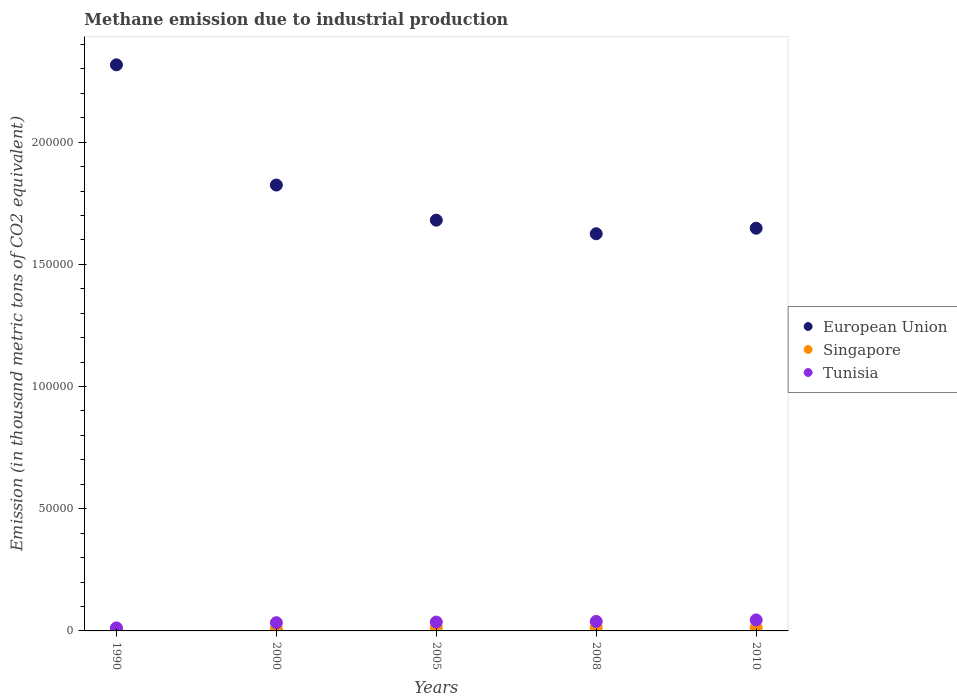How many different coloured dotlines are there?
Your answer should be compact. 3. What is the amount of methane emitted in European Union in 2000?
Offer a terse response. 1.82e+05. Across all years, what is the maximum amount of methane emitted in Tunisia?
Provide a succinct answer. 4497.8. Across all years, what is the minimum amount of methane emitted in Singapore?
Ensure brevity in your answer.  406.8. In which year was the amount of methane emitted in Tunisia maximum?
Your answer should be compact. 2010. In which year was the amount of methane emitted in European Union minimum?
Give a very brief answer. 2008. What is the total amount of methane emitted in Tunisia in the graph?
Offer a terse response. 1.66e+04. What is the difference between the amount of methane emitted in Tunisia in 1990 and that in 2005?
Keep it short and to the point. -2383.1. What is the difference between the amount of methane emitted in Tunisia in 2005 and the amount of methane emitted in Singapore in 2008?
Provide a short and direct response. 2233.4. What is the average amount of methane emitted in Singapore per year?
Offer a terse response. 1082.82. In the year 2005, what is the difference between the amount of methane emitted in Singapore and amount of methane emitted in European Union?
Provide a succinct answer. -1.67e+05. What is the ratio of the amount of methane emitted in Tunisia in 1990 to that in 2005?
Your answer should be very brief. 0.34. Is the amount of methane emitted in Tunisia in 1990 less than that in 2005?
Provide a succinct answer. Yes. What is the difference between the highest and the second highest amount of methane emitted in Tunisia?
Your answer should be compact. 606.2. What is the difference between the highest and the lowest amount of methane emitted in Tunisia?
Make the answer very short. 3260.8. In how many years, is the amount of methane emitted in European Union greater than the average amount of methane emitted in European Union taken over all years?
Offer a very short reply. 2. Is the sum of the amount of methane emitted in Tunisia in 1990 and 2000 greater than the maximum amount of methane emitted in European Union across all years?
Provide a succinct answer. No. How many years are there in the graph?
Your response must be concise. 5. Are the values on the major ticks of Y-axis written in scientific E-notation?
Your answer should be very brief. No. Where does the legend appear in the graph?
Offer a terse response. Center right. What is the title of the graph?
Give a very brief answer. Methane emission due to industrial production. Does "Finland" appear as one of the legend labels in the graph?
Your answer should be very brief. No. What is the label or title of the Y-axis?
Give a very brief answer. Emission (in thousand metric tons of CO2 equivalent). What is the Emission (in thousand metric tons of CO2 equivalent) of European Union in 1990?
Your answer should be compact. 2.32e+05. What is the Emission (in thousand metric tons of CO2 equivalent) in Singapore in 1990?
Keep it short and to the point. 406.8. What is the Emission (in thousand metric tons of CO2 equivalent) in Tunisia in 1990?
Ensure brevity in your answer.  1237. What is the Emission (in thousand metric tons of CO2 equivalent) in European Union in 2000?
Make the answer very short. 1.82e+05. What is the Emission (in thousand metric tons of CO2 equivalent) in Singapore in 2000?
Offer a very short reply. 893.5. What is the Emission (in thousand metric tons of CO2 equivalent) of Tunisia in 2000?
Provide a short and direct response. 3368.9. What is the Emission (in thousand metric tons of CO2 equivalent) of European Union in 2005?
Give a very brief answer. 1.68e+05. What is the Emission (in thousand metric tons of CO2 equivalent) in Singapore in 2005?
Your answer should be very brief. 1383. What is the Emission (in thousand metric tons of CO2 equivalent) of Tunisia in 2005?
Make the answer very short. 3620.1. What is the Emission (in thousand metric tons of CO2 equivalent) in European Union in 2008?
Your answer should be very brief. 1.63e+05. What is the Emission (in thousand metric tons of CO2 equivalent) of Singapore in 2008?
Offer a very short reply. 1386.7. What is the Emission (in thousand metric tons of CO2 equivalent) in Tunisia in 2008?
Offer a terse response. 3891.6. What is the Emission (in thousand metric tons of CO2 equivalent) in European Union in 2010?
Ensure brevity in your answer.  1.65e+05. What is the Emission (in thousand metric tons of CO2 equivalent) of Singapore in 2010?
Provide a succinct answer. 1344.1. What is the Emission (in thousand metric tons of CO2 equivalent) of Tunisia in 2010?
Your answer should be very brief. 4497.8. Across all years, what is the maximum Emission (in thousand metric tons of CO2 equivalent) in European Union?
Offer a terse response. 2.32e+05. Across all years, what is the maximum Emission (in thousand metric tons of CO2 equivalent) of Singapore?
Give a very brief answer. 1386.7. Across all years, what is the maximum Emission (in thousand metric tons of CO2 equivalent) of Tunisia?
Give a very brief answer. 4497.8. Across all years, what is the minimum Emission (in thousand metric tons of CO2 equivalent) of European Union?
Keep it short and to the point. 1.63e+05. Across all years, what is the minimum Emission (in thousand metric tons of CO2 equivalent) of Singapore?
Offer a terse response. 406.8. Across all years, what is the minimum Emission (in thousand metric tons of CO2 equivalent) in Tunisia?
Provide a succinct answer. 1237. What is the total Emission (in thousand metric tons of CO2 equivalent) in European Union in the graph?
Your response must be concise. 9.09e+05. What is the total Emission (in thousand metric tons of CO2 equivalent) in Singapore in the graph?
Keep it short and to the point. 5414.1. What is the total Emission (in thousand metric tons of CO2 equivalent) of Tunisia in the graph?
Your answer should be compact. 1.66e+04. What is the difference between the Emission (in thousand metric tons of CO2 equivalent) in European Union in 1990 and that in 2000?
Provide a short and direct response. 4.92e+04. What is the difference between the Emission (in thousand metric tons of CO2 equivalent) in Singapore in 1990 and that in 2000?
Provide a succinct answer. -486.7. What is the difference between the Emission (in thousand metric tons of CO2 equivalent) in Tunisia in 1990 and that in 2000?
Provide a short and direct response. -2131.9. What is the difference between the Emission (in thousand metric tons of CO2 equivalent) in European Union in 1990 and that in 2005?
Offer a terse response. 6.36e+04. What is the difference between the Emission (in thousand metric tons of CO2 equivalent) of Singapore in 1990 and that in 2005?
Provide a succinct answer. -976.2. What is the difference between the Emission (in thousand metric tons of CO2 equivalent) of Tunisia in 1990 and that in 2005?
Keep it short and to the point. -2383.1. What is the difference between the Emission (in thousand metric tons of CO2 equivalent) in European Union in 1990 and that in 2008?
Ensure brevity in your answer.  6.91e+04. What is the difference between the Emission (in thousand metric tons of CO2 equivalent) in Singapore in 1990 and that in 2008?
Provide a succinct answer. -979.9. What is the difference between the Emission (in thousand metric tons of CO2 equivalent) in Tunisia in 1990 and that in 2008?
Your answer should be very brief. -2654.6. What is the difference between the Emission (in thousand metric tons of CO2 equivalent) in European Union in 1990 and that in 2010?
Offer a very short reply. 6.69e+04. What is the difference between the Emission (in thousand metric tons of CO2 equivalent) in Singapore in 1990 and that in 2010?
Your answer should be compact. -937.3. What is the difference between the Emission (in thousand metric tons of CO2 equivalent) in Tunisia in 1990 and that in 2010?
Offer a terse response. -3260.8. What is the difference between the Emission (in thousand metric tons of CO2 equivalent) in European Union in 2000 and that in 2005?
Ensure brevity in your answer.  1.44e+04. What is the difference between the Emission (in thousand metric tons of CO2 equivalent) of Singapore in 2000 and that in 2005?
Keep it short and to the point. -489.5. What is the difference between the Emission (in thousand metric tons of CO2 equivalent) in Tunisia in 2000 and that in 2005?
Offer a very short reply. -251.2. What is the difference between the Emission (in thousand metric tons of CO2 equivalent) in European Union in 2000 and that in 2008?
Your answer should be compact. 1.99e+04. What is the difference between the Emission (in thousand metric tons of CO2 equivalent) in Singapore in 2000 and that in 2008?
Make the answer very short. -493.2. What is the difference between the Emission (in thousand metric tons of CO2 equivalent) of Tunisia in 2000 and that in 2008?
Give a very brief answer. -522.7. What is the difference between the Emission (in thousand metric tons of CO2 equivalent) of European Union in 2000 and that in 2010?
Offer a very short reply. 1.77e+04. What is the difference between the Emission (in thousand metric tons of CO2 equivalent) of Singapore in 2000 and that in 2010?
Your response must be concise. -450.6. What is the difference between the Emission (in thousand metric tons of CO2 equivalent) in Tunisia in 2000 and that in 2010?
Your answer should be very brief. -1128.9. What is the difference between the Emission (in thousand metric tons of CO2 equivalent) of European Union in 2005 and that in 2008?
Your response must be concise. 5562. What is the difference between the Emission (in thousand metric tons of CO2 equivalent) in Tunisia in 2005 and that in 2008?
Offer a terse response. -271.5. What is the difference between the Emission (in thousand metric tons of CO2 equivalent) in European Union in 2005 and that in 2010?
Offer a terse response. 3298.2. What is the difference between the Emission (in thousand metric tons of CO2 equivalent) of Singapore in 2005 and that in 2010?
Give a very brief answer. 38.9. What is the difference between the Emission (in thousand metric tons of CO2 equivalent) of Tunisia in 2005 and that in 2010?
Give a very brief answer. -877.7. What is the difference between the Emission (in thousand metric tons of CO2 equivalent) of European Union in 2008 and that in 2010?
Offer a terse response. -2263.8. What is the difference between the Emission (in thousand metric tons of CO2 equivalent) of Singapore in 2008 and that in 2010?
Your answer should be very brief. 42.6. What is the difference between the Emission (in thousand metric tons of CO2 equivalent) of Tunisia in 2008 and that in 2010?
Your answer should be compact. -606.2. What is the difference between the Emission (in thousand metric tons of CO2 equivalent) of European Union in 1990 and the Emission (in thousand metric tons of CO2 equivalent) of Singapore in 2000?
Ensure brevity in your answer.  2.31e+05. What is the difference between the Emission (in thousand metric tons of CO2 equivalent) of European Union in 1990 and the Emission (in thousand metric tons of CO2 equivalent) of Tunisia in 2000?
Make the answer very short. 2.28e+05. What is the difference between the Emission (in thousand metric tons of CO2 equivalent) of Singapore in 1990 and the Emission (in thousand metric tons of CO2 equivalent) of Tunisia in 2000?
Your response must be concise. -2962.1. What is the difference between the Emission (in thousand metric tons of CO2 equivalent) of European Union in 1990 and the Emission (in thousand metric tons of CO2 equivalent) of Singapore in 2005?
Your answer should be compact. 2.30e+05. What is the difference between the Emission (in thousand metric tons of CO2 equivalent) of European Union in 1990 and the Emission (in thousand metric tons of CO2 equivalent) of Tunisia in 2005?
Provide a succinct answer. 2.28e+05. What is the difference between the Emission (in thousand metric tons of CO2 equivalent) in Singapore in 1990 and the Emission (in thousand metric tons of CO2 equivalent) in Tunisia in 2005?
Keep it short and to the point. -3213.3. What is the difference between the Emission (in thousand metric tons of CO2 equivalent) of European Union in 1990 and the Emission (in thousand metric tons of CO2 equivalent) of Singapore in 2008?
Provide a succinct answer. 2.30e+05. What is the difference between the Emission (in thousand metric tons of CO2 equivalent) in European Union in 1990 and the Emission (in thousand metric tons of CO2 equivalent) in Tunisia in 2008?
Your answer should be compact. 2.28e+05. What is the difference between the Emission (in thousand metric tons of CO2 equivalent) in Singapore in 1990 and the Emission (in thousand metric tons of CO2 equivalent) in Tunisia in 2008?
Your response must be concise. -3484.8. What is the difference between the Emission (in thousand metric tons of CO2 equivalent) in European Union in 1990 and the Emission (in thousand metric tons of CO2 equivalent) in Singapore in 2010?
Keep it short and to the point. 2.30e+05. What is the difference between the Emission (in thousand metric tons of CO2 equivalent) in European Union in 1990 and the Emission (in thousand metric tons of CO2 equivalent) in Tunisia in 2010?
Give a very brief answer. 2.27e+05. What is the difference between the Emission (in thousand metric tons of CO2 equivalent) of Singapore in 1990 and the Emission (in thousand metric tons of CO2 equivalent) of Tunisia in 2010?
Your answer should be compact. -4091. What is the difference between the Emission (in thousand metric tons of CO2 equivalent) in European Union in 2000 and the Emission (in thousand metric tons of CO2 equivalent) in Singapore in 2005?
Keep it short and to the point. 1.81e+05. What is the difference between the Emission (in thousand metric tons of CO2 equivalent) of European Union in 2000 and the Emission (in thousand metric tons of CO2 equivalent) of Tunisia in 2005?
Your answer should be very brief. 1.79e+05. What is the difference between the Emission (in thousand metric tons of CO2 equivalent) of Singapore in 2000 and the Emission (in thousand metric tons of CO2 equivalent) of Tunisia in 2005?
Your answer should be compact. -2726.6. What is the difference between the Emission (in thousand metric tons of CO2 equivalent) of European Union in 2000 and the Emission (in thousand metric tons of CO2 equivalent) of Singapore in 2008?
Offer a very short reply. 1.81e+05. What is the difference between the Emission (in thousand metric tons of CO2 equivalent) of European Union in 2000 and the Emission (in thousand metric tons of CO2 equivalent) of Tunisia in 2008?
Give a very brief answer. 1.79e+05. What is the difference between the Emission (in thousand metric tons of CO2 equivalent) in Singapore in 2000 and the Emission (in thousand metric tons of CO2 equivalent) in Tunisia in 2008?
Keep it short and to the point. -2998.1. What is the difference between the Emission (in thousand metric tons of CO2 equivalent) in European Union in 2000 and the Emission (in thousand metric tons of CO2 equivalent) in Singapore in 2010?
Provide a short and direct response. 1.81e+05. What is the difference between the Emission (in thousand metric tons of CO2 equivalent) of European Union in 2000 and the Emission (in thousand metric tons of CO2 equivalent) of Tunisia in 2010?
Make the answer very short. 1.78e+05. What is the difference between the Emission (in thousand metric tons of CO2 equivalent) in Singapore in 2000 and the Emission (in thousand metric tons of CO2 equivalent) in Tunisia in 2010?
Offer a terse response. -3604.3. What is the difference between the Emission (in thousand metric tons of CO2 equivalent) of European Union in 2005 and the Emission (in thousand metric tons of CO2 equivalent) of Singapore in 2008?
Your response must be concise. 1.67e+05. What is the difference between the Emission (in thousand metric tons of CO2 equivalent) of European Union in 2005 and the Emission (in thousand metric tons of CO2 equivalent) of Tunisia in 2008?
Give a very brief answer. 1.64e+05. What is the difference between the Emission (in thousand metric tons of CO2 equivalent) in Singapore in 2005 and the Emission (in thousand metric tons of CO2 equivalent) in Tunisia in 2008?
Your answer should be very brief. -2508.6. What is the difference between the Emission (in thousand metric tons of CO2 equivalent) in European Union in 2005 and the Emission (in thousand metric tons of CO2 equivalent) in Singapore in 2010?
Your answer should be very brief. 1.67e+05. What is the difference between the Emission (in thousand metric tons of CO2 equivalent) of European Union in 2005 and the Emission (in thousand metric tons of CO2 equivalent) of Tunisia in 2010?
Give a very brief answer. 1.64e+05. What is the difference between the Emission (in thousand metric tons of CO2 equivalent) of Singapore in 2005 and the Emission (in thousand metric tons of CO2 equivalent) of Tunisia in 2010?
Offer a terse response. -3114.8. What is the difference between the Emission (in thousand metric tons of CO2 equivalent) of European Union in 2008 and the Emission (in thousand metric tons of CO2 equivalent) of Singapore in 2010?
Offer a very short reply. 1.61e+05. What is the difference between the Emission (in thousand metric tons of CO2 equivalent) in European Union in 2008 and the Emission (in thousand metric tons of CO2 equivalent) in Tunisia in 2010?
Keep it short and to the point. 1.58e+05. What is the difference between the Emission (in thousand metric tons of CO2 equivalent) in Singapore in 2008 and the Emission (in thousand metric tons of CO2 equivalent) in Tunisia in 2010?
Give a very brief answer. -3111.1. What is the average Emission (in thousand metric tons of CO2 equivalent) of European Union per year?
Keep it short and to the point. 1.82e+05. What is the average Emission (in thousand metric tons of CO2 equivalent) of Singapore per year?
Provide a short and direct response. 1082.82. What is the average Emission (in thousand metric tons of CO2 equivalent) in Tunisia per year?
Your response must be concise. 3323.08. In the year 1990, what is the difference between the Emission (in thousand metric tons of CO2 equivalent) of European Union and Emission (in thousand metric tons of CO2 equivalent) of Singapore?
Ensure brevity in your answer.  2.31e+05. In the year 1990, what is the difference between the Emission (in thousand metric tons of CO2 equivalent) in European Union and Emission (in thousand metric tons of CO2 equivalent) in Tunisia?
Ensure brevity in your answer.  2.30e+05. In the year 1990, what is the difference between the Emission (in thousand metric tons of CO2 equivalent) in Singapore and Emission (in thousand metric tons of CO2 equivalent) in Tunisia?
Your response must be concise. -830.2. In the year 2000, what is the difference between the Emission (in thousand metric tons of CO2 equivalent) of European Union and Emission (in thousand metric tons of CO2 equivalent) of Singapore?
Your response must be concise. 1.82e+05. In the year 2000, what is the difference between the Emission (in thousand metric tons of CO2 equivalent) of European Union and Emission (in thousand metric tons of CO2 equivalent) of Tunisia?
Give a very brief answer. 1.79e+05. In the year 2000, what is the difference between the Emission (in thousand metric tons of CO2 equivalent) of Singapore and Emission (in thousand metric tons of CO2 equivalent) of Tunisia?
Ensure brevity in your answer.  -2475.4. In the year 2005, what is the difference between the Emission (in thousand metric tons of CO2 equivalent) in European Union and Emission (in thousand metric tons of CO2 equivalent) in Singapore?
Provide a succinct answer. 1.67e+05. In the year 2005, what is the difference between the Emission (in thousand metric tons of CO2 equivalent) in European Union and Emission (in thousand metric tons of CO2 equivalent) in Tunisia?
Ensure brevity in your answer.  1.64e+05. In the year 2005, what is the difference between the Emission (in thousand metric tons of CO2 equivalent) in Singapore and Emission (in thousand metric tons of CO2 equivalent) in Tunisia?
Your answer should be compact. -2237.1. In the year 2008, what is the difference between the Emission (in thousand metric tons of CO2 equivalent) in European Union and Emission (in thousand metric tons of CO2 equivalent) in Singapore?
Your answer should be very brief. 1.61e+05. In the year 2008, what is the difference between the Emission (in thousand metric tons of CO2 equivalent) of European Union and Emission (in thousand metric tons of CO2 equivalent) of Tunisia?
Keep it short and to the point. 1.59e+05. In the year 2008, what is the difference between the Emission (in thousand metric tons of CO2 equivalent) of Singapore and Emission (in thousand metric tons of CO2 equivalent) of Tunisia?
Your answer should be compact. -2504.9. In the year 2010, what is the difference between the Emission (in thousand metric tons of CO2 equivalent) in European Union and Emission (in thousand metric tons of CO2 equivalent) in Singapore?
Give a very brief answer. 1.63e+05. In the year 2010, what is the difference between the Emission (in thousand metric tons of CO2 equivalent) of European Union and Emission (in thousand metric tons of CO2 equivalent) of Tunisia?
Ensure brevity in your answer.  1.60e+05. In the year 2010, what is the difference between the Emission (in thousand metric tons of CO2 equivalent) in Singapore and Emission (in thousand metric tons of CO2 equivalent) in Tunisia?
Offer a very short reply. -3153.7. What is the ratio of the Emission (in thousand metric tons of CO2 equivalent) of European Union in 1990 to that in 2000?
Give a very brief answer. 1.27. What is the ratio of the Emission (in thousand metric tons of CO2 equivalent) of Singapore in 1990 to that in 2000?
Offer a very short reply. 0.46. What is the ratio of the Emission (in thousand metric tons of CO2 equivalent) in Tunisia in 1990 to that in 2000?
Make the answer very short. 0.37. What is the ratio of the Emission (in thousand metric tons of CO2 equivalent) of European Union in 1990 to that in 2005?
Give a very brief answer. 1.38. What is the ratio of the Emission (in thousand metric tons of CO2 equivalent) of Singapore in 1990 to that in 2005?
Make the answer very short. 0.29. What is the ratio of the Emission (in thousand metric tons of CO2 equivalent) of Tunisia in 1990 to that in 2005?
Your answer should be very brief. 0.34. What is the ratio of the Emission (in thousand metric tons of CO2 equivalent) in European Union in 1990 to that in 2008?
Make the answer very short. 1.43. What is the ratio of the Emission (in thousand metric tons of CO2 equivalent) of Singapore in 1990 to that in 2008?
Your answer should be very brief. 0.29. What is the ratio of the Emission (in thousand metric tons of CO2 equivalent) in Tunisia in 1990 to that in 2008?
Ensure brevity in your answer.  0.32. What is the ratio of the Emission (in thousand metric tons of CO2 equivalent) in European Union in 1990 to that in 2010?
Your answer should be very brief. 1.41. What is the ratio of the Emission (in thousand metric tons of CO2 equivalent) in Singapore in 1990 to that in 2010?
Make the answer very short. 0.3. What is the ratio of the Emission (in thousand metric tons of CO2 equivalent) in Tunisia in 1990 to that in 2010?
Your response must be concise. 0.28. What is the ratio of the Emission (in thousand metric tons of CO2 equivalent) of European Union in 2000 to that in 2005?
Make the answer very short. 1.09. What is the ratio of the Emission (in thousand metric tons of CO2 equivalent) of Singapore in 2000 to that in 2005?
Give a very brief answer. 0.65. What is the ratio of the Emission (in thousand metric tons of CO2 equivalent) of Tunisia in 2000 to that in 2005?
Keep it short and to the point. 0.93. What is the ratio of the Emission (in thousand metric tons of CO2 equivalent) in European Union in 2000 to that in 2008?
Give a very brief answer. 1.12. What is the ratio of the Emission (in thousand metric tons of CO2 equivalent) in Singapore in 2000 to that in 2008?
Provide a succinct answer. 0.64. What is the ratio of the Emission (in thousand metric tons of CO2 equivalent) in Tunisia in 2000 to that in 2008?
Provide a short and direct response. 0.87. What is the ratio of the Emission (in thousand metric tons of CO2 equivalent) in European Union in 2000 to that in 2010?
Offer a very short reply. 1.11. What is the ratio of the Emission (in thousand metric tons of CO2 equivalent) in Singapore in 2000 to that in 2010?
Your answer should be very brief. 0.66. What is the ratio of the Emission (in thousand metric tons of CO2 equivalent) in Tunisia in 2000 to that in 2010?
Provide a short and direct response. 0.75. What is the ratio of the Emission (in thousand metric tons of CO2 equivalent) of European Union in 2005 to that in 2008?
Offer a terse response. 1.03. What is the ratio of the Emission (in thousand metric tons of CO2 equivalent) of Singapore in 2005 to that in 2008?
Provide a short and direct response. 1. What is the ratio of the Emission (in thousand metric tons of CO2 equivalent) of Tunisia in 2005 to that in 2008?
Offer a very short reply. 0.93. What is the ratio of the Emission (in thousand metric tons of CO2 equivalent) of Singapore in 2005 to that in 2010?
Provide a succinct answer. 1.03. What is the ratio of the Emission (in thousand metric tons of CO2 equivalent) of Tunisia in 2005 to that in 2010?
Make the answer very short. 0.8. What is the ratio of the Emission (in thousand metric tons of CO2 equivalent) of European Union in 2008 to that in 2010?
Provide a succinct answer. 0.99. What is the ratio of the Emission (in thousand metric tons of CO2 equivalent) in Singapore in 2008 to that in 2010?
Offer a very short reply. 1.03. What is the ratio of the Emission (in thousand metric tons of CO2 equivalent) in Tunisia in 2008 to that in 2010?
Your answer should be compact. 0.87. What is the difference between the highest and the second highest Emission (in thousand metric tons of CO2 equivalent) in European Union?
Offer a very short reply. 4.92e+04. What is the difference between the highest and the second highest Emission (in thousand metric tons of CO2 equivalent) in Tunisia?
Your answer should be very brief. 606.2. What is the difference between the highest and the lowest Emission (in thousand metric tons of CO2 equivalent) of European Union?
Make the answer very short. 6.91e+04. What is the difference between the highest and the lowest Emission (in thousand metric tons of CO2 equivalent) of Singapore?
Ensure brevity in your answer.  979.9. What is the difference between the highest and the lowest Emission (in thousand metric tons of CO2 equivalent) of Tunisia?
Provide a short and direct response. 3260.8. 